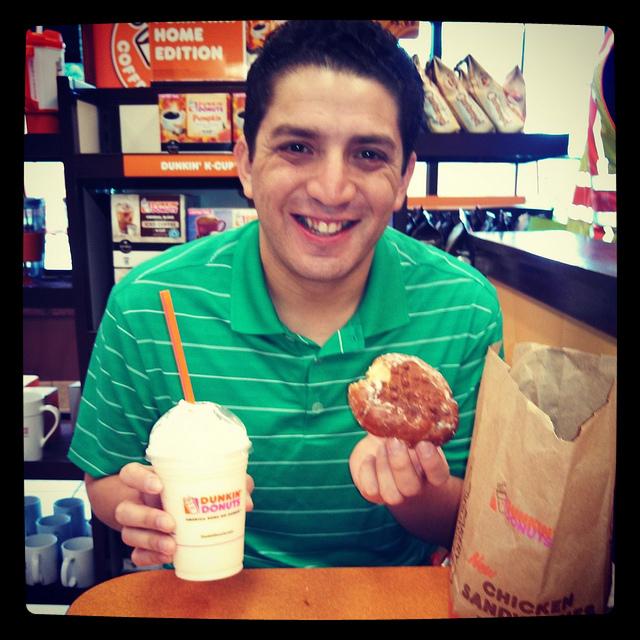What kind of doughnut is this man holding?
Concise answer only. Filled. What type of sandwich is advertised on the bag?
Answer briefly. Chicken. What color is the icing on the donut?
Concise answer only. Clear. What restaurant is behind the man?
Be succinct. Dunkin donuts. Where are the glasses?
Quick response, please. Shelf. What color is the man's shirt?
Keep it brief. Green. Where is the drink from?
Answer briefly. Dunkin donuts. 